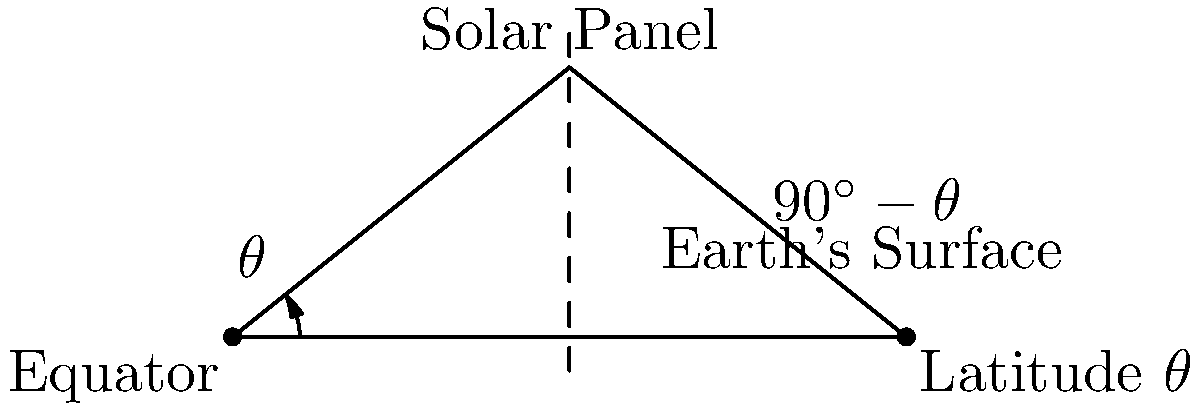As an astronomy enthusiast, you're helping design a solar power system for your observatory in Odisha, India. Given that Odisha's latitude is approximately 20°N, what would be the optimal tilt angle for a fixed solar panel to maximize its annual energy collection? To determine the optimal tilt angle for a fixed solar panel, we need to consider the following steps:

1. Understand the relationship between latitude and optimal tilt:
   The general rule of thumb is that the optimal tilt angle is approximately equal to the latitude of the location.

2. Consider Odisha's latitude:
   Odisha is located at approximately 20°N latitude.

3. Apply the rule of thumb:
   The optimal tilt angle would be close to 20°.

4. Fine-tuning for annual optimization:
   For fixed panels optimized for year-round performance, we often subtract 10-15° from the latitude to account for seasonal variations. This adjustment helps balance summer and winter performance.

5. Calculate the final optimal angle:
   $20° - 10° = 10°$

6. Interpret the result:
   A tilt angle of about 10° from horizontal would be optimal for year-round energy collection in Odisha.

Note: The exact optimal angle may vary slightly due to local climate conditions, but this calculation provides a good starting point for maximizing annual solar energy collection.
Answer: Approximately 10° 